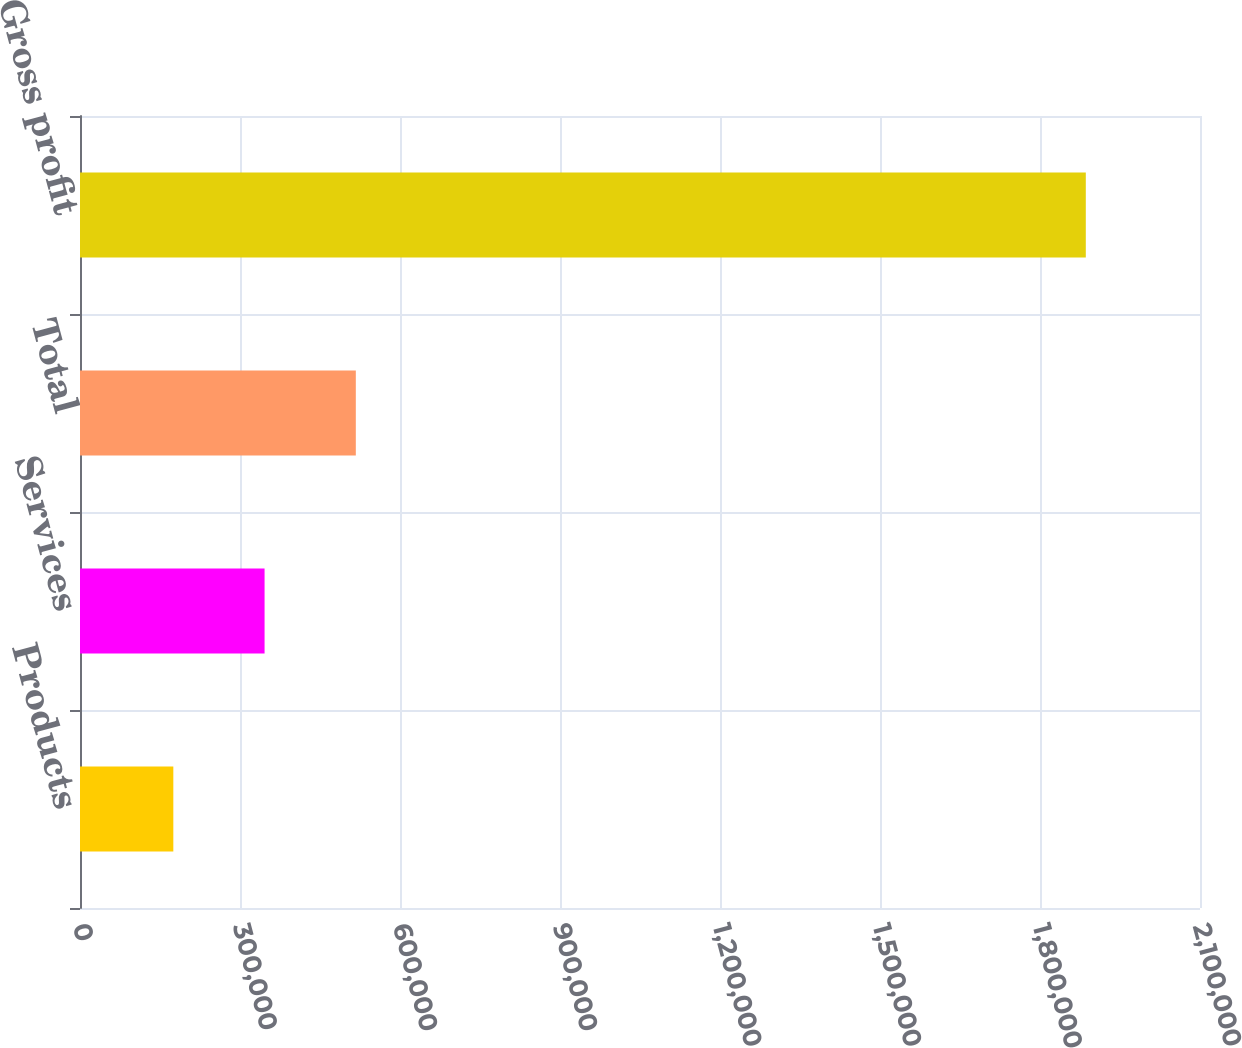Convert chart to OTSL. <chart><loc_0><loc_0><loc_500><loc_500><bar_chart><fcel>Products<fcel>Services<fcel>Total<fcel>Gross profit<nl><fcel>174986<fcel>346074<fcel>517163<fcel>1.88587e+06<nl></chart> 